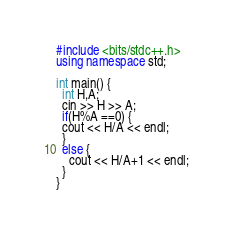<code> <loc_0><loc_0><loc_500><loc_500><_C++_>#include <bits/stdc++.h>
using namespace std;

int main() {
  int H,A;
  cin >> H >> A;
  if(H%A ==0) {
  cout << H/A << endl;
  }
  else {
    cout << H/A+1 << endl;
  }
}
</code> 